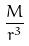Convert formula to latex. <formula><loc_0><loc_0><loc_500><loc_500>\frac { M } { r ^ { 3 } }</formula> 